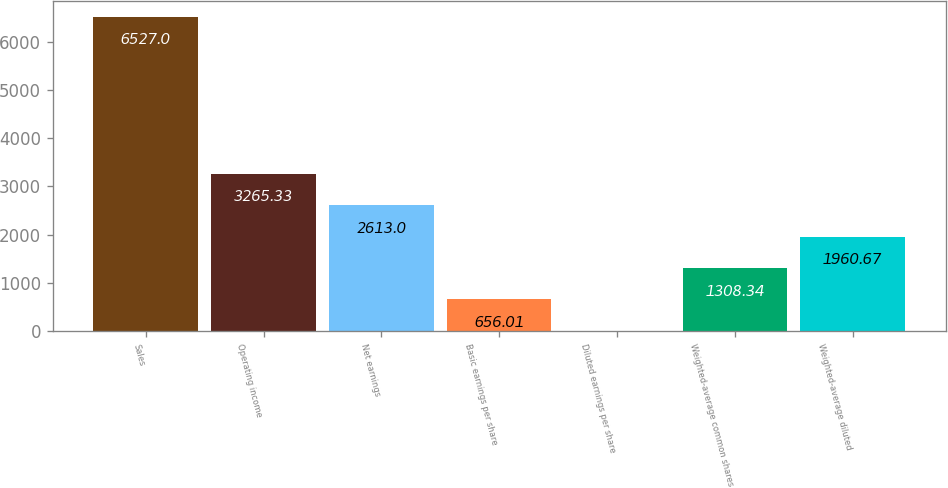Convert chart to OTSL. <chart><loc_0><loc_0><loc_500><loc_500><bar_chart><fcel>Sales<fcel>Operating income<fcel>Net earnings<fcel>Basic earnings per share<fcel>Diluted earnings per share<fcel>Weighted-average common shares<fcel>Weighted-average diluted<nl><fcel>6527<fcel>3265.33<fcel>2613<fcel>656.01<fcel>3.68<fcel>1308.34<fcel>1960.67<nl></chart> 